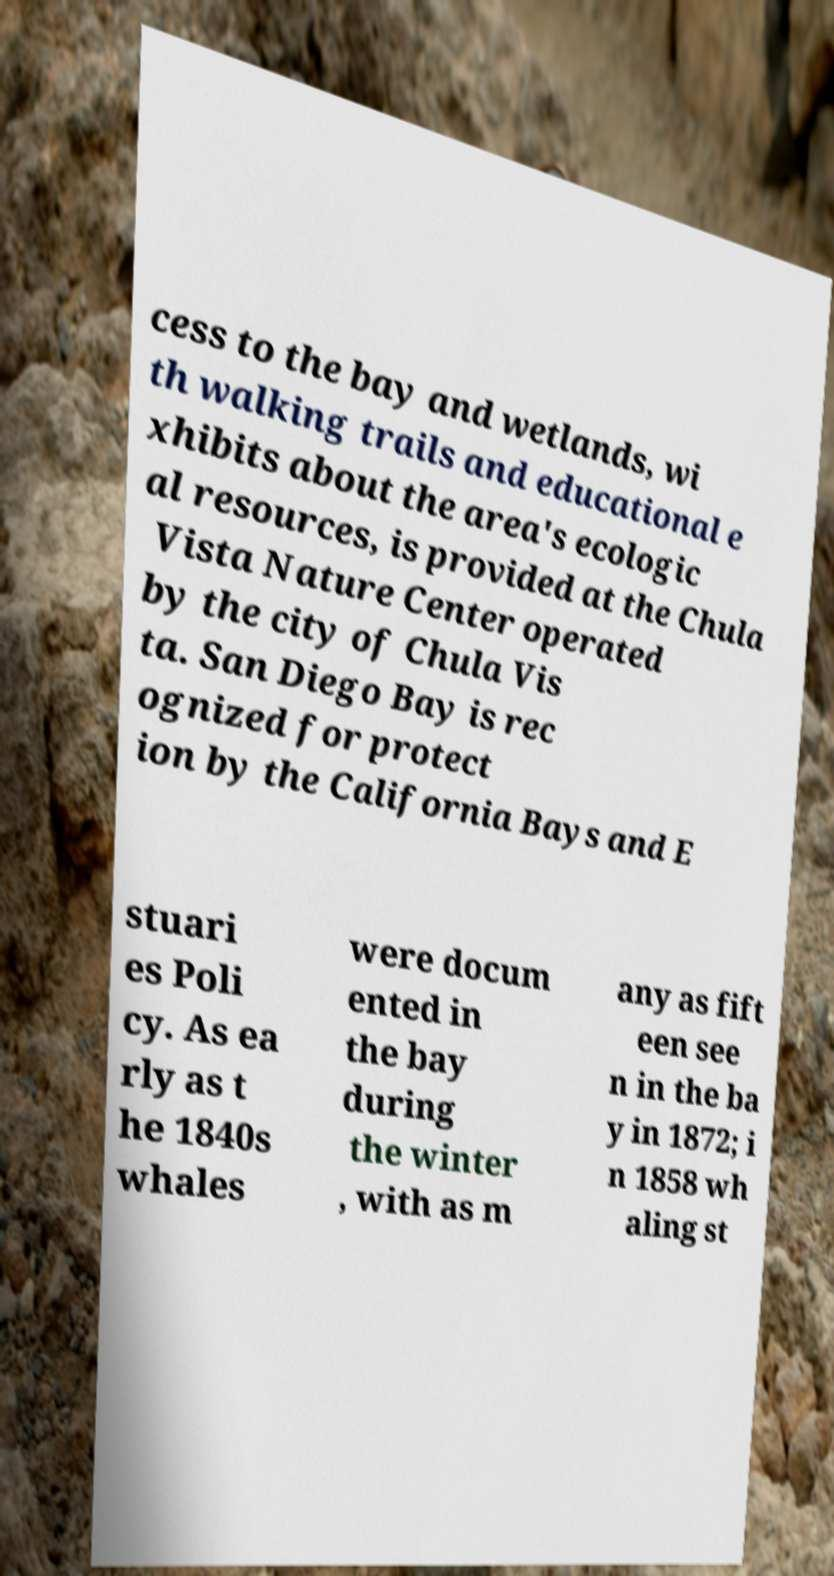Please read and relay the text visible in this image. What does it say? cess to the bay and wetlands, wi th walking trails and educational e xhibits about the area's ecologic al resources, is provided at the Chula Vista Nature Center operated by the city of Chula Vis ta. San Diego Bay is rec ognized for protect ion by the California Bays and E stuari es Poli cy. As ea rly as t he 1840s whales were docum ented in the bay during the winter , with as m any as fift een see n in the ba y in 1872; i n 1858 wh aling st 